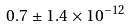<formula> <loc_0><loc_0><loc_500><loc_500>0 . 7 \pm 1 . 4 \times 1 0 ^ { - 1 2 }</formula> 